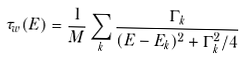<formula> <loc_0><loc_0><loc_500><loc_500>\tau _ { w } ( E ) = \frac { 1 } { M } \sum _ { k } \frac { \Gamma _ { k } } { ( E - E _ { k } ) ^ { 2 } + \Gamma _ { k } ^ { 2 } / 4 }</formula> 